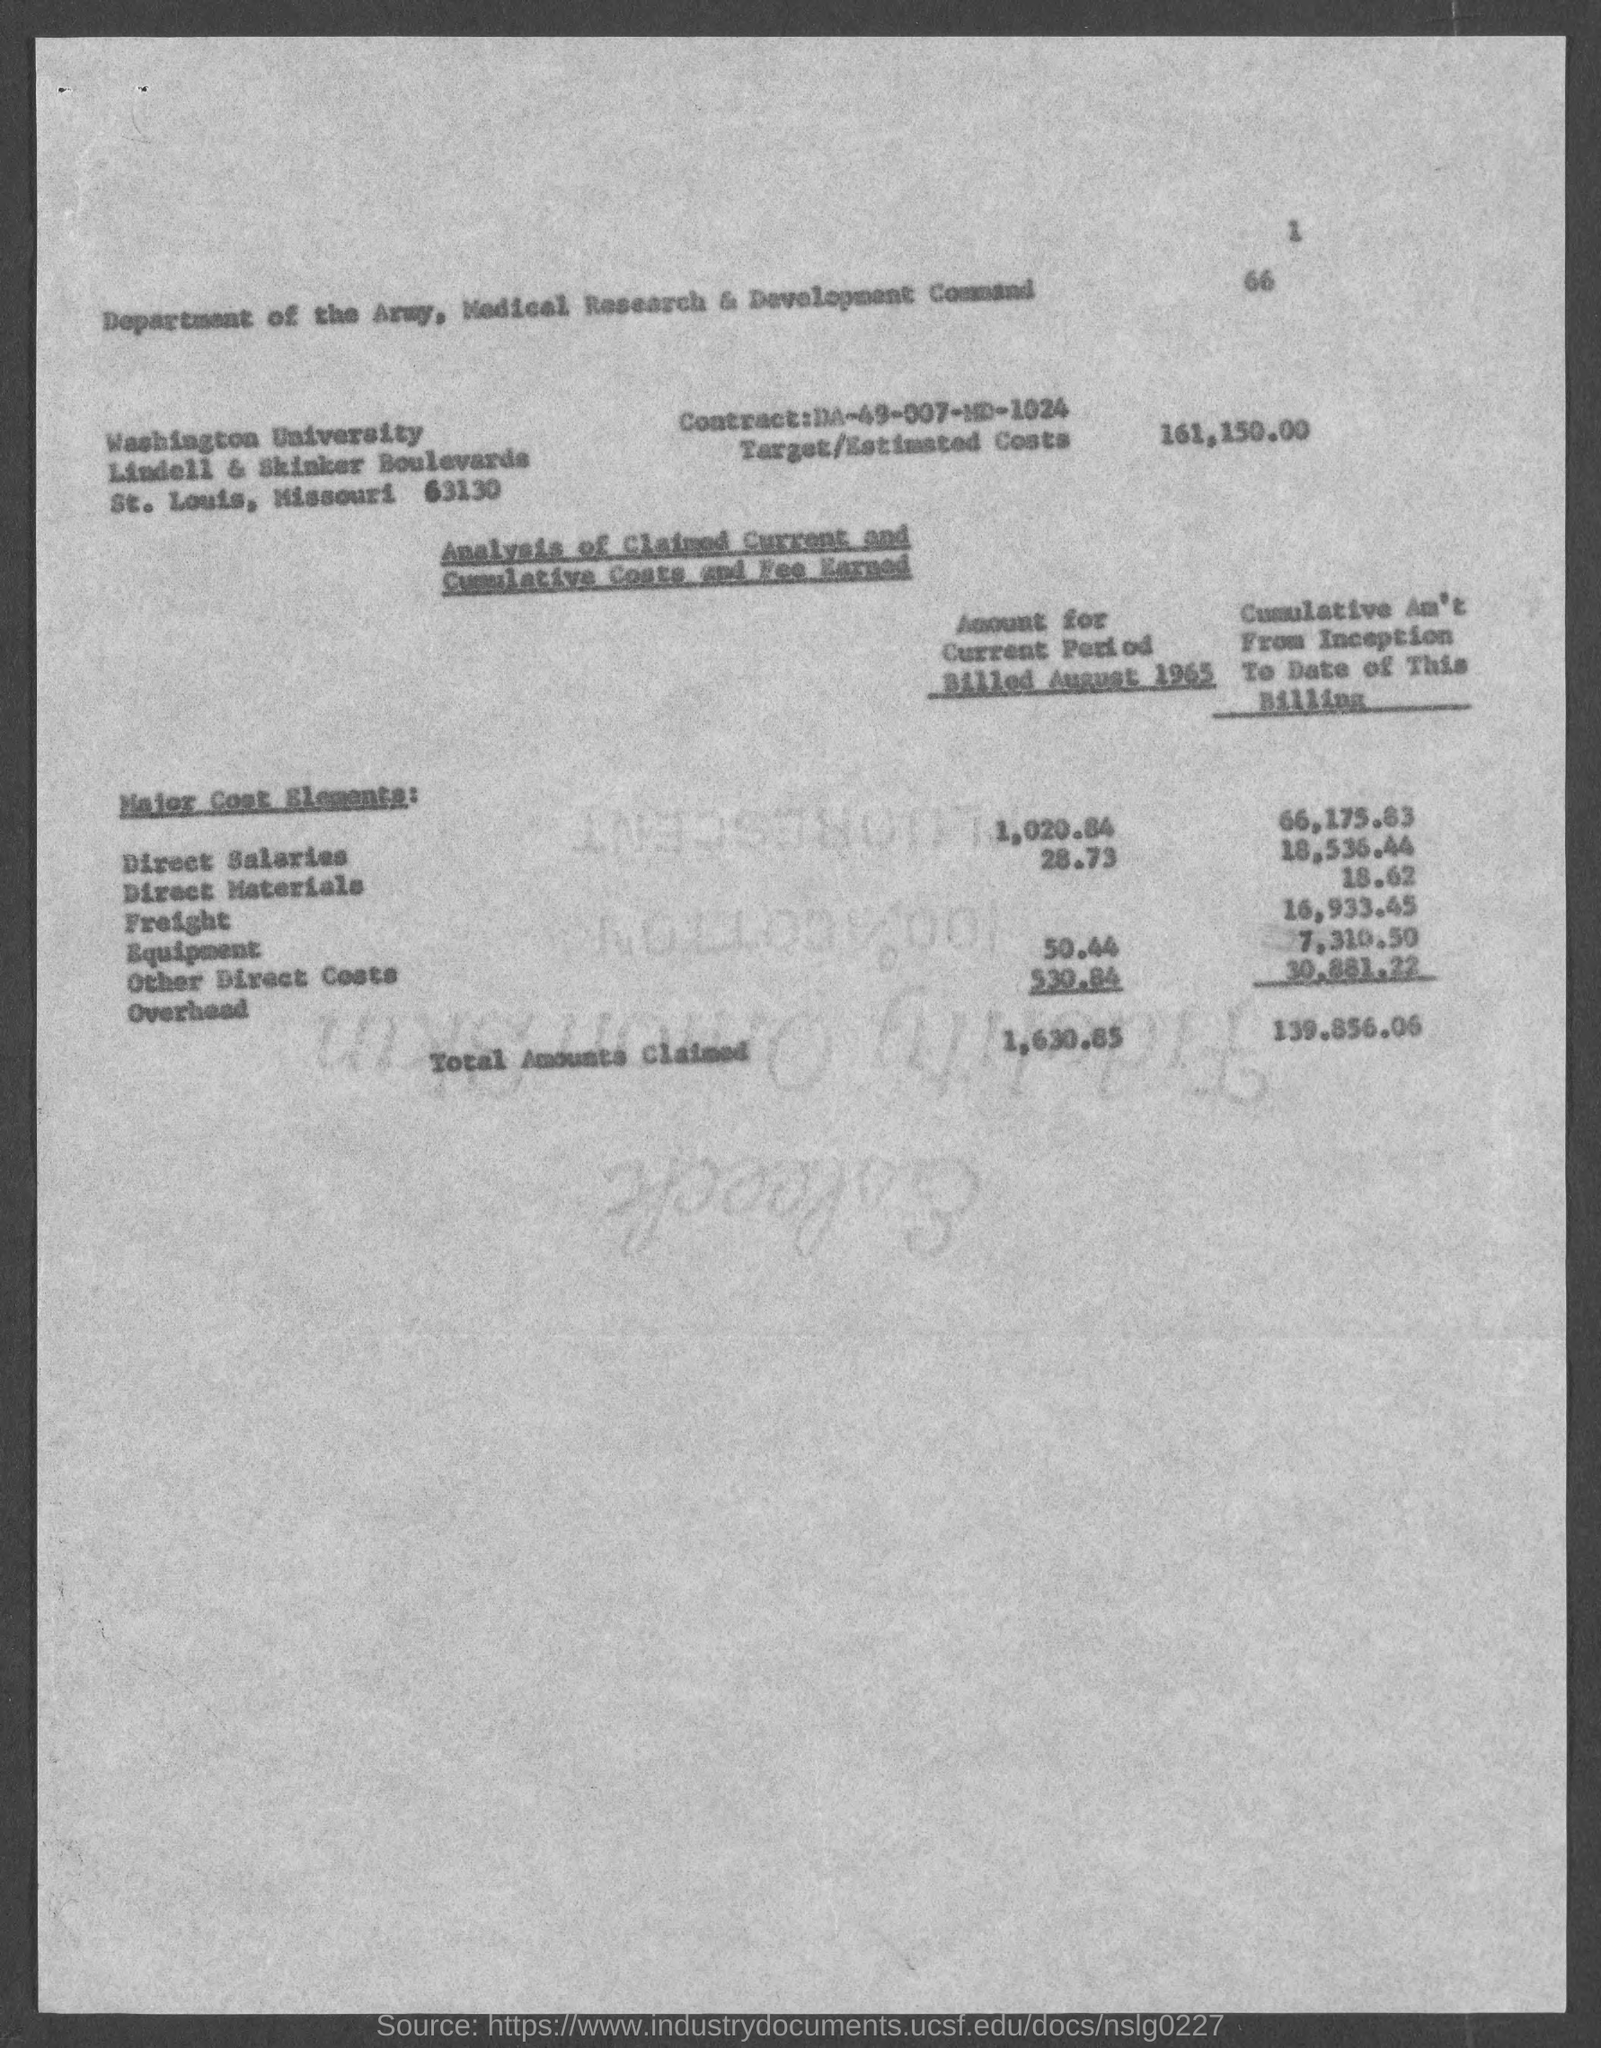Highlight a few significant elements in this photo. The cumulative amount for equipment from the inception to the current date is $16,933.45. The overhead cost for the current period billed in August 1965 was 530.84. The total amount claimed from the beginning of this billing to the current date is $139,856.06. The direct salaries amount for the current period billed in August 1965 was $1,020.84. The amount of direct materials billed in August 1965 was $28.73. 